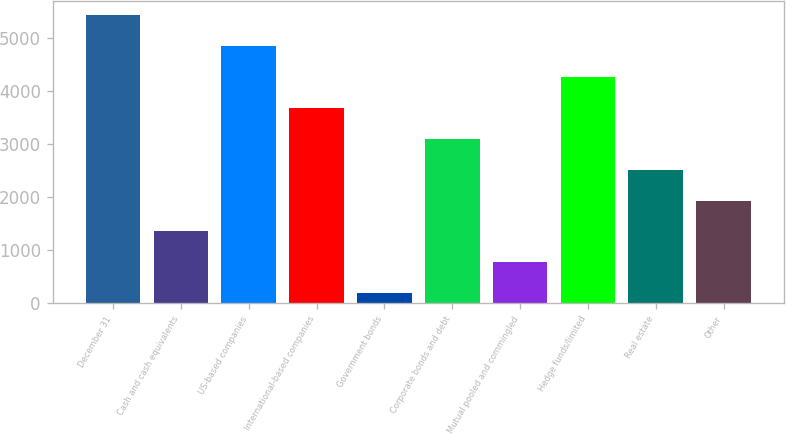Convert chart to OTSL. <chart><loc_0><loc_0><loc_500><loc_500><bar_chart><fcel>December 31<fcel>Cash and cash equivalents<fcel>US-based companies<fcel>International-based companies<fcel>Government bonds<fcel>Corporate bonds and debt<fcel>Mutual pooled and commingled<fcel>Hedge funds/limited<fcel>Real estate<fcel>Other<nl><fcel>5443.5<fcel>1352<fcel>4859<fcel>3690<fcel>183<fcel>3105.5<fcel>767.5<fcel>4274.5<fcel>2521<fcel>1936.5<nl></chart> 